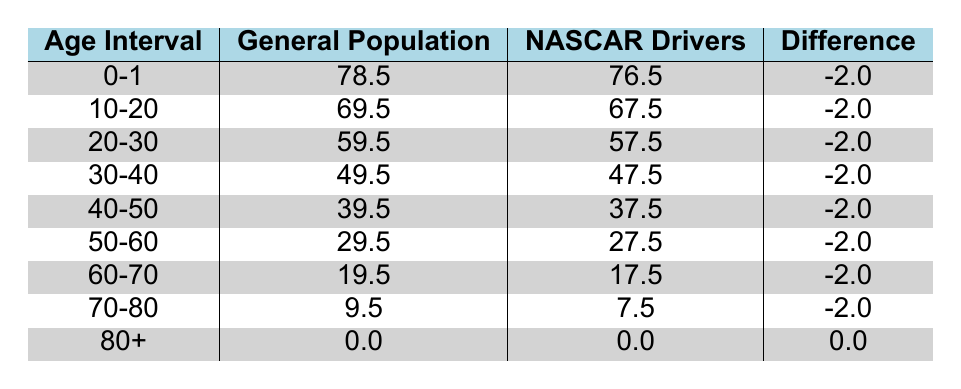What is the life expectancy for the general population in the age interval 30-40? Referring to the table, under the age interval "30-40," the life expectancy for the general population is listed as 49.5.
Answer: 49.5 What is the life expectancy for NASCAR drivers in the age interval 50-60? The table shows that under the age interval "50-60," the life expectancy for NASCAR drivers is 27.5.
Answer: 27.5 Is the life expectancy for NASCAR drivers in the age interval 70-80 higher than that of the general population? In the table, the life expectancy for NASCAR drivers in the "70-80" age interval is 7.5, while for the general population it is 9.5. Since 7.5 is less than 9.5, the statement is false.
Answer: No What is the difference in life expectancy between NASCAR drivers and the general population in the age interval 60-70? According to the table, for the "60-70" age interval, the life expectancy for the general population is 19.5, and for NASCAR drivers, it is 17.5. The difference is calculated as 19.5 - 17.5 = 2.0.
Answer: 2.0 In which age interval does the general population have the highest life expectancy? Looking at the table, the general population has the highest life expectancy in the "0-1" age interval at 78.5.
Answer: 0-1 Calculating the average life expectancy of NASCAR drivers across all age intervals, what is the result? The life expectancies for NASCAR drivers are 76.5, 67.5, 57.5, 47.5, 37.5, 27.5, 17.5, 7.5, and 0.0. Adding these values gives 333.0. Dividing by the total number of intervals (8) results in an average of 41.625.
Answer: 41.625 Do NASCAR drivers have a consistently lower life expectancy than the general population in all age intervals? By examining the table, for every age interval except "80+," NASCAR drivers have lower life expectancies than the general population. Hence, the statement is true.
Answer: Yes What is the life expectancy difference in the “20-30” age interval? The life expectancy for the general population in the "20-30" age interval is 59.5, and for NASCAR drivers, it is 57.5. The difference is 59.5 - 57.5 = 2.0.
Answer: 2.0 